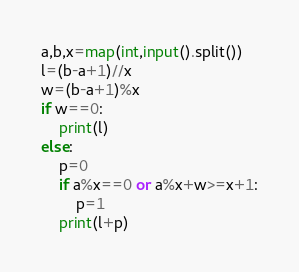Convert code to text. <code><loc_0><loc_0><loc_500><loc_500><_Python_>a,b,x=map(int,input().split())
l=(b-a+1)//x
w=(b-a+1)%x
if w==0:
    print(l)
else:
    p=0
    if a%x==0 or a%x+w>=x+1:
        p=1
    print(l+p)</code> 